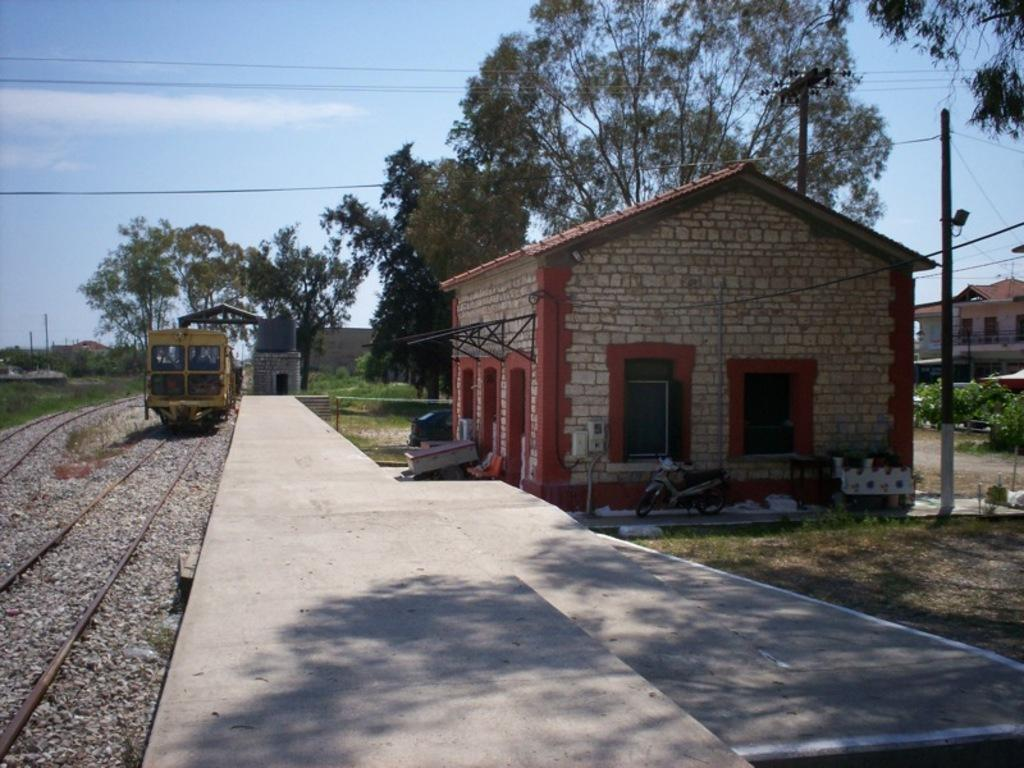What mode of transportation can be seen on the left side of the image? There is a train on the track in the image. Where is the train located in relation to the other elements in the image? The train is on the left side of the image. What structure is in the middle of the image? There is a platform in the middle of the image. What type of building is on the right side of the image? There is a home on the right side of the image. What can be seen behind the home in the image? Trees are visible behind the home. What is visible above the home in the image? The sky is visible above the home, and clouds are present in the sky. What type of hen is sitting on the roof of the train in the image? There is no hen present in the image; it only features a train, a platform, a home, trees, and the sky. 